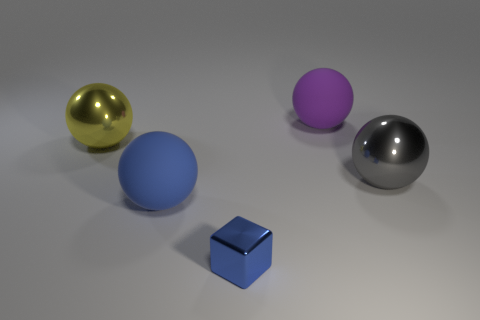Subtract 1 balls. How many balls are left? 3 Add 1 gray metallic balls. How many objects exist? 6 Subtract all spheres. How many objects are left? 1 Subtract all small blue metallic things. Subtract all big yellow objects. How many objects are left? 3 Add 5 big yellow metal objects. How many big yellow metal objects are left? 6 Add 4 large purple matte things. How many large purple matte things exist? 5 Subtract 0 yellow cubes. How many objects are left? 5 